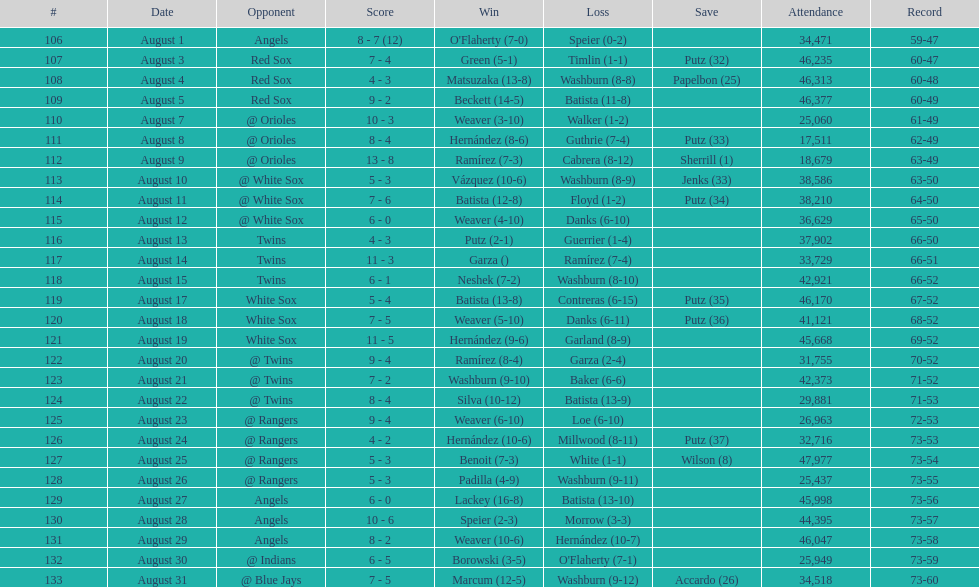Number of wins during stretch 5. 